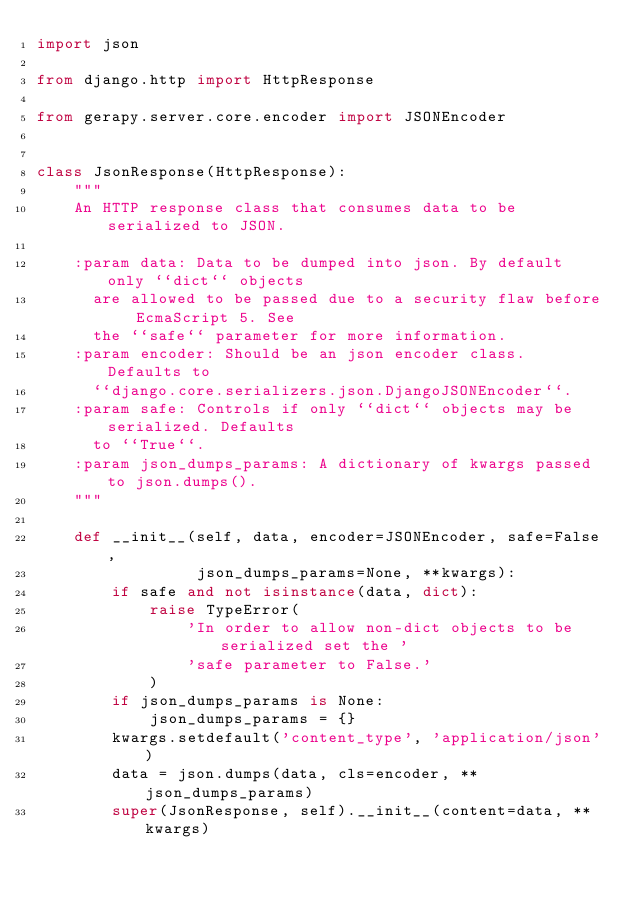Convert code to text. <code><loc_0><loc_0><loc_500><loc_500><_Python_>import json

from django.http import HttpResponse

from gerapy.server.core.encoder import JSONEncoder


class JsonResponse(HttpResponse):
    """
    An HTTP response class that consumes data to be serialized to JSON.

    :param data: Data to be dumped into json. By default only ``dict`` objects
      are allowed to be passed due to a security flaw before EcmaScript 5. See
      the ``safe`` parameter for more information.
    :param encoder: Should be an json encoder class. Defaults to
      ``django.core.serializers.json.DjangoJSONEncoder``.
    :param safe: Controls if only ``dict`` objects may be serialized. Defaults
      to ``True``.
    :param json_dumps_params: A dictionary of kwargs passed to json.dumps().
    """
    
    def __init__(self, data, encoder=JSONEncoder, safe=False,
                 json_dumps_params=None, **kwargs):
        if safe and not isinstance(data, dict):
            raise TypeError(
                'In order to allow non-dict objects to be serialized set the '
                'safe parameter to False.'
            )
        if json_dumps_params is None:
            json_dumps_params = {}
        kwargs.setdefault('content_type', 'application/json')
        data = json.dumps(data, cls=encoder, **json_dumps_params)
        super(JsonResponse, self).__init__(content=data, **kwargs)
</code> 